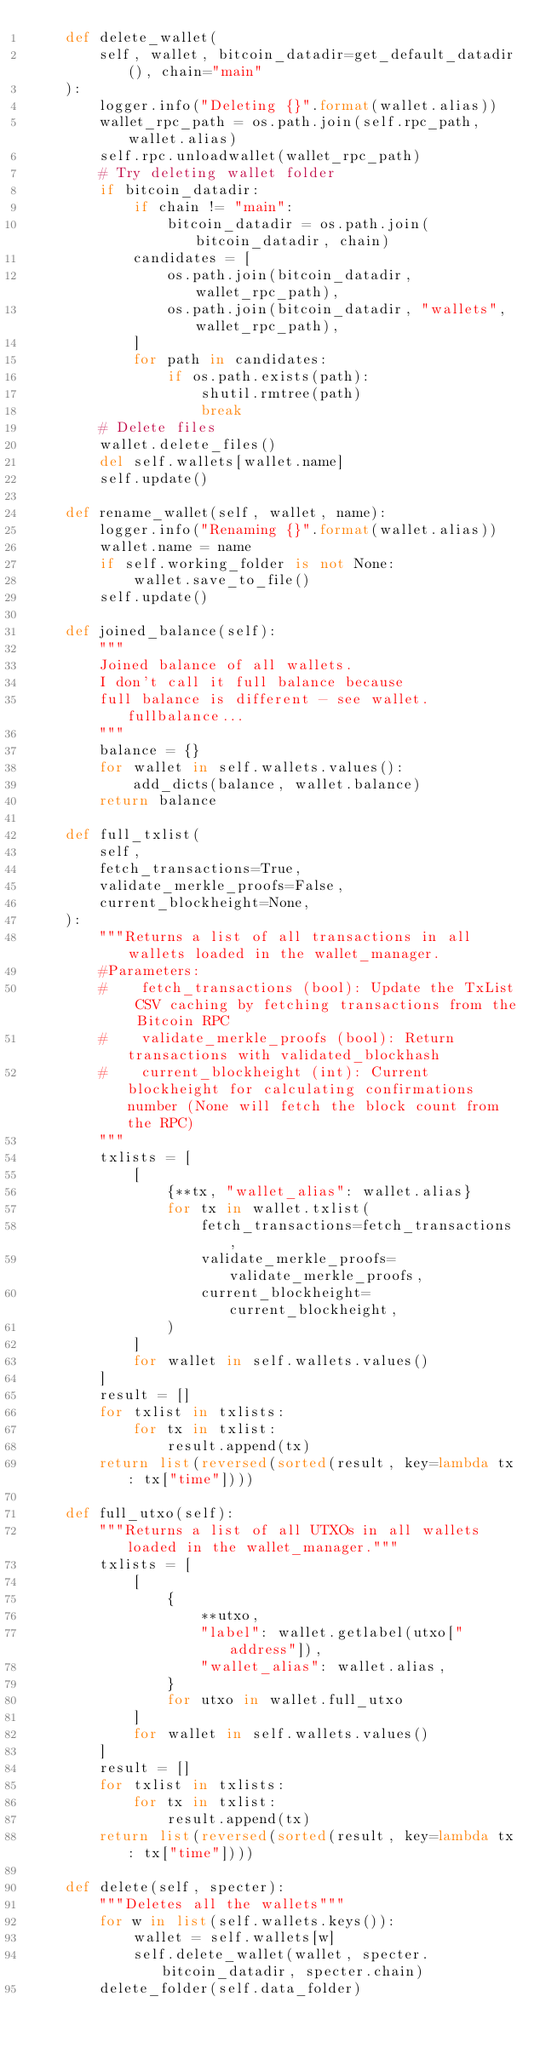Convert code to text. <code><loc_0><loc_0><loc_500><loc_500><_Python_>    def delete_wallet(
        self, wallet, bitcoin_datadir=get_default_datadir(), chain="main"
    ):
        logger.info("Deleting {}".format(wallet.alias))
        wallet_rpc_path = os.path.join(self.rpc_path, wallet.alias)
        self.rpc.unloadwallet(wallet_rpc_path)
        # Try deleting wallet folder
        if bitcoin_datadir:
            if chain != "main":
                bitcoin_datadir = os.path.join(bitcoin_datadir, chain)
            candidates = [
                os.path.join(bitcoin_datadir, wallet_rpc_path),
                os.path.join(bitcoin_datadir, "wallets", wallet_rpc_path),
            ]
            for path in candidates:
                if os.path.exists(path):
                    shutil.rmtree(path)
                    break
        # Delete files
        wallet.delete_files()
        del self.wallets[wallet.name]
        self.update()

    def rename_wallet(self, wallet, name):
        logger.info("Renaming {}".format(wallet.alias))
        wallet.name = name
        if self.working_folder is not None:
            wallet.save_to_file()
        self.update()

    def joined_balance(self):
        """
        Joined balance of all wallets.
        I don't call it full balance because
        full balance is different - see wallet.fullbalance...
        """
        balance = {}
        for wallet in self.wallets.values():
            add_dicts(balance, wallet.balance)
        return balance

    def full_txlist(
        self,
        fetch_transactions=True,
        validate_merkle_proofs=False,
        current_blockheight=None,
    ):
        """Returns a list of all transactions in all wallets loaded in the wallet_manager.
        #Parameters:
        #    fetch_transactions (bool): Update the TxList CSV caching by fetching transactions from the Bitcoin RPC
        #    validate_merkle_proofs (bool): Return transactions with validated_blockhash
        #    current_blockheight (int): Current blockheight for calculating confirmations number (None will fetch the block count from the RPC)
        """
        txlists = [
            [
                {**tx, "wallet_alias": wallet.alias}
                for tx in wallet.txlist(
                    fetch_transactions=fetch_transactions,
                    validate_merkle_proofs=validate_merkle_proofs,
                    current_blockheight=current_blockheight,
                )
            ]
            for wallet in self.wallets.values()
        ]
        result = []
        for txlist in txlists:
            for tx in txlist:
                result.append(tx)
        return list(reversed(sorted(result, key=lambda tx: tx["time"])))

    def full_utxo(self):
        """Returns a list of all UTXOs in all wallets loaded in the wallet_manager."""
        txlists = [
            [
                {
                    **utxo,
                    "label": wallet.getlabel(utxo["address"]),
                    "wallet_alias": wallet.alias,
                }
                for utxo in wallet.full_utxo
            ]
            for wallet in self.wallets.values()
        ]
        result = []
        for txlist in txlists:
            for tx in txlist:
                result.append(tx)
        return list(reversed(sorted(result, key=lambda tx: tx["time"])))

    def delete(self, specter):
        """Deletes all the wallets"""
        for w in list(self.wallets.keys()):
            wallet = self.wallets[w]
            self.delete_wallet(wallet, specter.bitcoin_datadir, specter.chain)
        delete_folder(self.data_folder)
</code> 